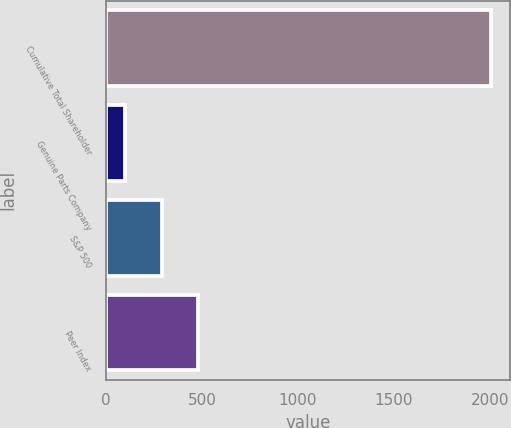<chart> <loc_0><loc_0><loc_500><loc_500><bar_chart><fcel>Cumulative Total Shareholder<fcel>Genuine Parts Company<fcel>S&P 500<fcel>Peer Index<nl><fcel>2008<fcel>100<fcel>290.8<fcel>481.6<nl></chart> 